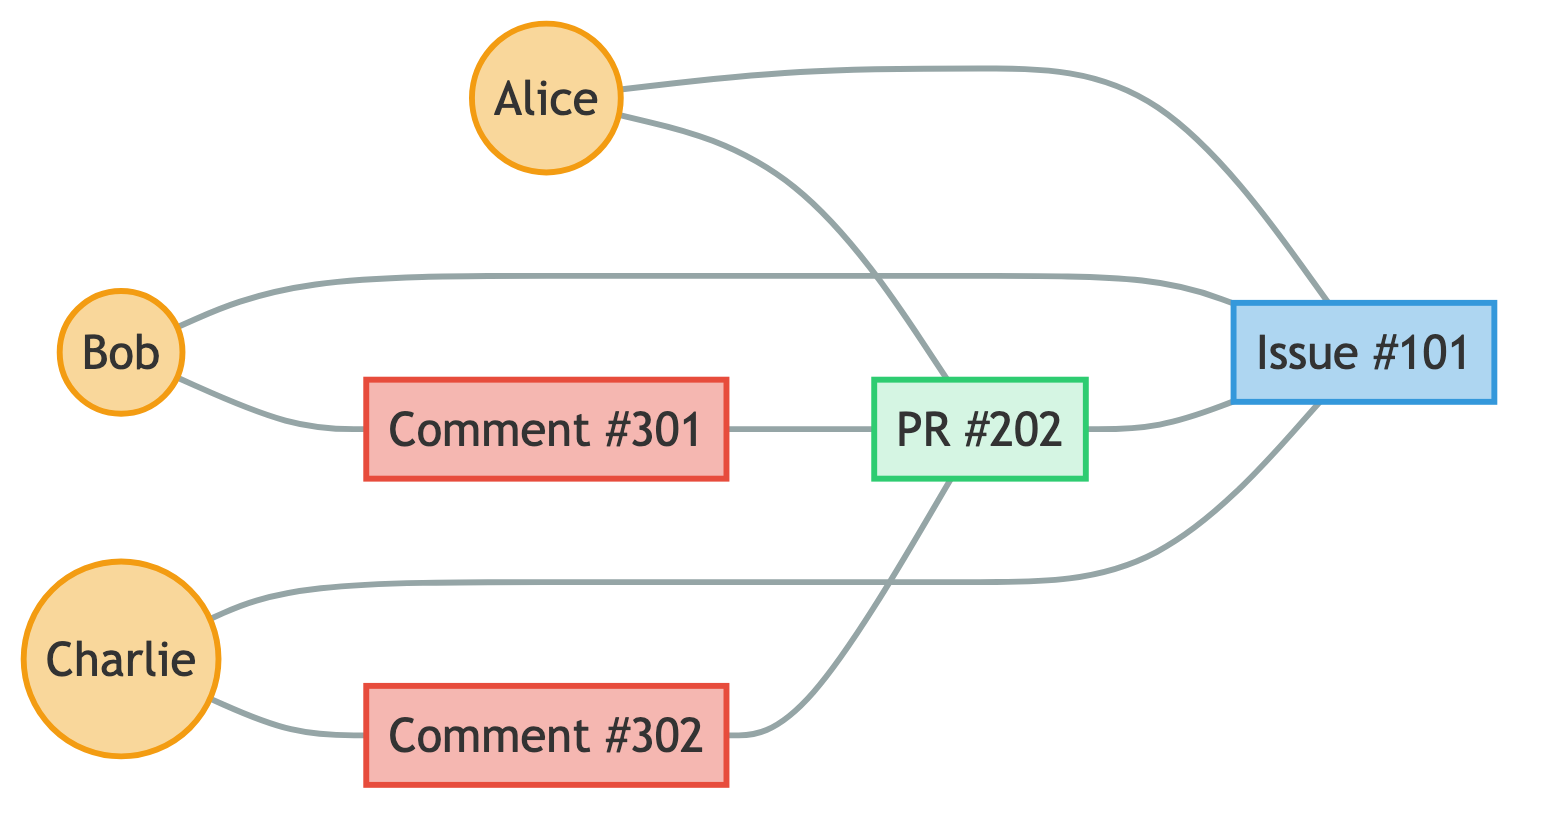What are the types of nodes present in the diagram? The diagram includes three types of nodes: Contributor, Issue, PullRequest, and Comment. We can identify these types by looking at the classifications given in the data ("type" field) for each node.
Answer: Contributor, Issue, PullRequest, Comment How many contributors are involved in the interaction network? By counting the nodes labeled as Contributors (Alice, Bob, and Charlie), we find there are three contributors total.
Answer: 3 Which user created the pull request #202? The edge labeled "created" between the user node for Alice and the node for pull request #202 indicates that Alice is the creator.
Answer: Alice What type of interaction exists between the pull request #202 and issue #101? There is a "resolves" interaction from pull request #202 to issue #101, suggesting that PR #202 is intended to address the issues raised in #101.
Answer: resolves How many total comments are made in the diagram? The diagram shows two distinct comment nodes (#301 and #302). Hence, we sum these nodes to determine there are two comments made overall.
Answer: 2 Which user commented on issue #101? There are two edges coming from Bob and Charlie to issue #101, indicating both users provided comments on the issue.
Answer: Bob, Charlie What is the relationship type between comment #301 and PR #202? There is a "commented_on" relationship labeled between comment #301 and pull request #202, indicating that comment #301 pertains to or is associated with PR #202.
Answer: commented_on How many edges connect to the issue #101? The edges connected to issue #101 are from Alice, Bob, Charlie, and PR #202, totaling four edges that link to the issue node.
Answer: 4 Which contributor created comment #302? The data indicates a direct connection from Charlie to comment #302, labeling him as the creator of that comment.
Answer: Charlie 